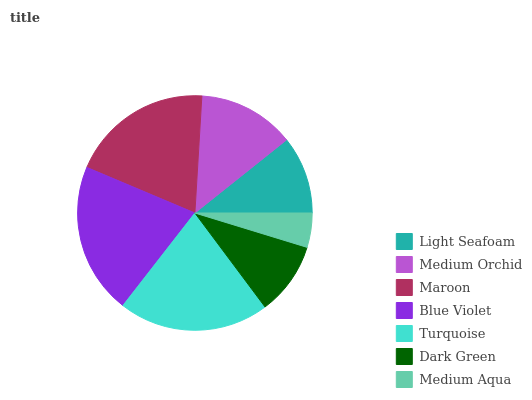Is Medium Aqua the minimum?
Answer yes or no. Yes. Is Blue Violet the maximum?
Answer yes or no. Yes. Is Medium Orchid the minimum?
Answer yes or no. No. Is Medium Orchid the maximum?
Answer yes or no. No. Is Medium Orchid greater than Light Seafoam?
Answer yes or no. Yes. Is Light Seafoam less than Medium Orchid?
Answer yes or no. Yes. Is Light Seafoam greater than Medium Orchid?
Answer yes or no. No. Is Medium Orchid less than Light Seafoam?
Answer yes or no. No. Is Medium Orchid the high median?
Answer yes or no. Yes. Is Medium Orchid the low median?
Answer yes or no. Yes. Is Maroon the high median?
Answer yes or no. No. Is Turquoise the low median?
Answer yes or no. No. 